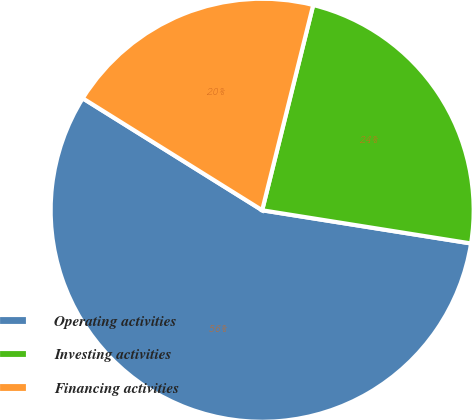Convert chart to OTSL. <chart><loc_0><loc_0><loc_500><loc_500><pie_chart><fcel>Operating activities<fcel>Investing activities<fcel>Financing activities<nl><fcel>56.37%<fcel>23.63%<fcel>20.0%<nl></chart> 